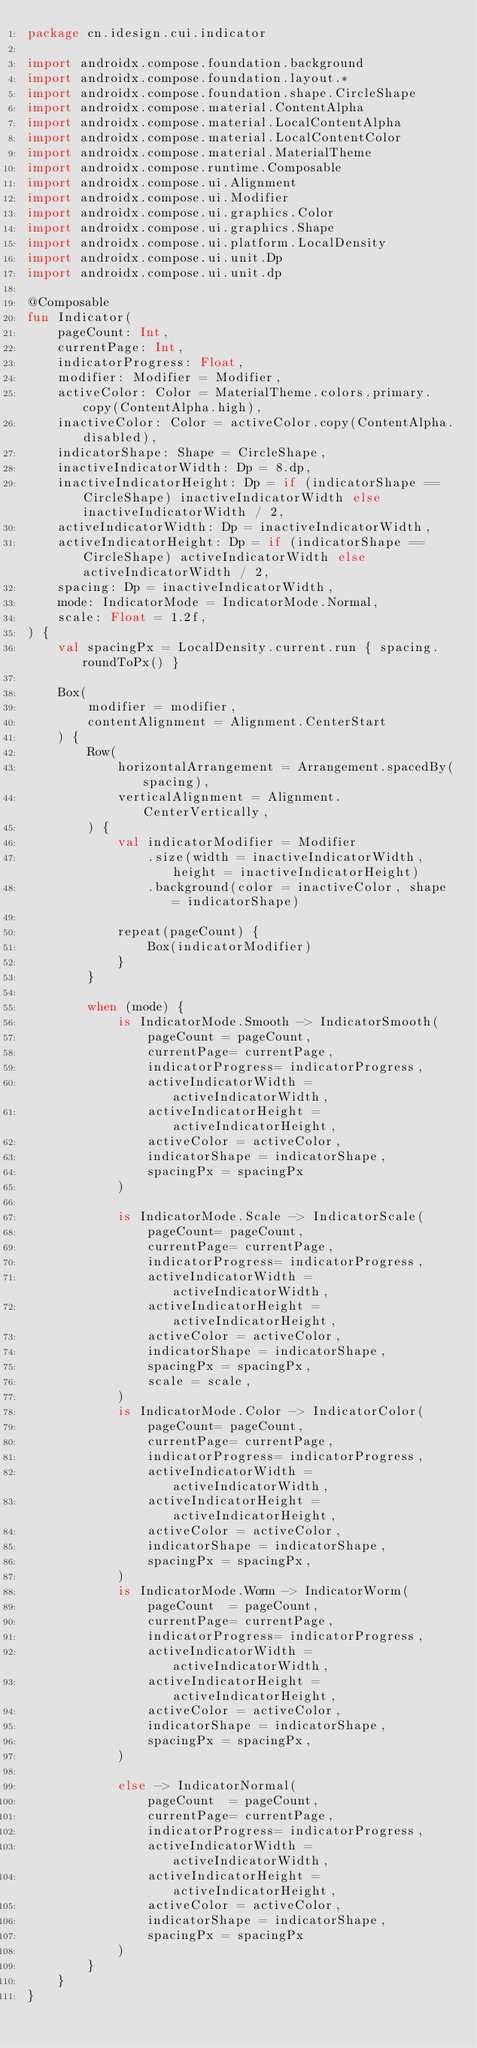<code> <loc_0><loc_0><loc_500><loc_500><_Kotlin_>package cn.idesign.cui.indicator

import androidx.compose.foundation.background
import androidx.compose.foundation.layout.*
import androidx.compose.foundation.shape.CircleShape
import androidx.compose.material.ContentAlpha
import androidx.compose.material.LocalContentAlpha
import androidx.compose.material.LocalContentColor
import androidx.compose.material.MaterialTheme
import androidx.compose.runtime.Composable
import androidx.compose.ui.Alignment
import androidx.compose.ui.Modifier
import androidx.compose.ui.graphics.Color
import androidx.compose.ui.graphics.Shape
import androidx.compose.ui.platform.LocalDensity
import androidx.compose.ui.unit.Dp
import androidx.compose.ui.unit.dp

@Composable
fun Indicator(
    pageCount: Int,
    currentPage: Int,
    indicatorProgress: Float,
    modifier: Modifier = Modifier,
    activeColor: Color = MaterialTheme.colors.primary.copy(ContentAlpha.high),
    inactiveColor: Color = activeColor.copy(ContentAlpha.disabled),
    indicatorShape: Shape = CircleShape,
    inactiveIndicatorWidth: Dp = 8.dp,
    inactiveIndicatorHeight: Dp = if (indicatorShape == CircleShape) inactiveIndicatorWidth else inactiveIndicatorWidth / 2,
    activeIndicatorWidth: Dp = inactiveIndicatorWidth,
    activeIndicatorHeight: Dp = if (indicatorShape == CircleShape) activeIndicatorWidth else activeIndicatorWidth / 2,
    spacing: Dp = inactiveIndicatorWidth,
    mode: IndicatorMode = IndicatorMode.Normal,
    scale: Float = 1.2f,
) {
    val spacingPx = LocalDensity.current.run { spacing.roundToPx() }

    Box(
        modifier = modifier,
        contentAlignment = Alignment.CenterStart
    ) {
        Row(
            horizontalArrangement = Arrangement.spacedBy(spacing),
            verticalAlignment = Alignment.CenterVertically,
        ) {
            val indicatorModifier = Modifier
                .size(width = inactiveIndicatorWidth, height = inactiveIndicatorHeight)
                .background(color = inactiveColor, shape = indicatorShape)

            repeat(pageCount) {
                Box(indicatorModifier)
            }
        }

        when (mode) {
            is IndicatorMode.Smooth -> IndicatorSmooth(
                pageCount = pageCount,
                currentPage= currentPage,
                indicatorProgress= indicatorProgress,
                activeIndicatorWidth = activeIndicatorWidth,
                activeIndicatorHeight = activeIndicatorHeight,
                activeColor = activeColor,
                indicatorShape = indicatorShape,
                spacingPx = spacingPx
            )

            is IndicatorMode.Scale -> IndicatorScale(
                pageCount= pageCount,
                currentPage= currentPage,
                indicatorProgress= indicatorProgress,
                activeIndicatorWidth = activeIndicatorWidth,
                activeIndicatorHeight = activeIndicatorHeight,
                activeColor = activeColor,
                indicatorShape = indicatorShape,
                spacingPx = spacingPx,
                scale = scale,
            )
            is IndicatorMode.Color -> IndicatorColor(
                pageCount= pageCount,
                currentPage= currentPage,
                indicatorProgress= indicatorProgress,
                activeIndicatorWidth = activeIndicatorWidth,
                activeIndicatorHeight = activeIndicatorHeight,
                activeColor = activeColor,
                indicatorShape = indicatorShape,
                spacingPx = spacingPx,
            )
            is IndicatorMode.Worm -> IndicatorWorm(
                pageCount  = pageCount,
                currentPage= currentPage,
                indicatorProgress= indicatorProgress,
                activeIndicatorWidth = activeIndicatorWidth,
                activeIndicatorHeight = activeIndicatorHeight,
                activeColor = activeColor,
                indicatorShape = indicatorShape,
                spacingPx = spacingPx,
            )

            else -> IndicatorNormal(
                pageCount  = pageCount,
                currentPage= currentPage,
                indicatorProgress= indicatorProgress,
                activeIndicatorWidth = activeIndicatorWidth,
                activeIndicatorHeight = activeIndicatorHeight,
                activeColor = activeColor,
                indicatorShape = indicatorShape,
                spacingPx = spacingPx
            )
        }
    }
}</code> 